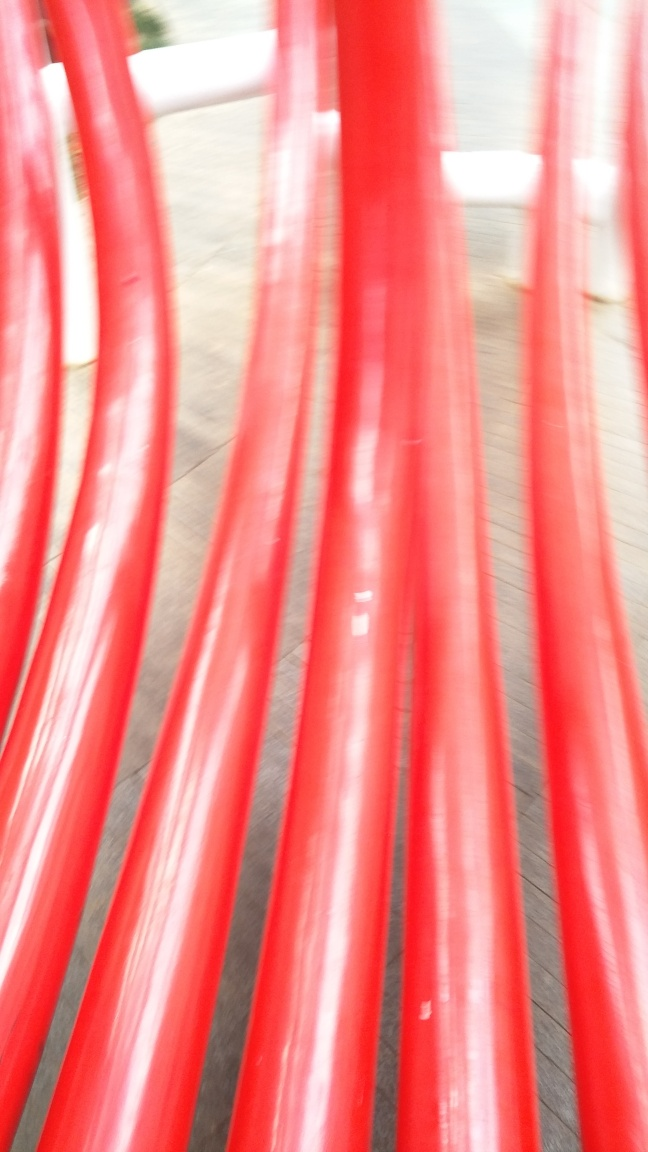Can you suggest what the red object might be used for? Although it's difficult to determine precisely due to the motion blur, the vibrant red color and curved shapes suggest they might be part of a public art sculpture or playground apparatus meant for climbing or interaction. 